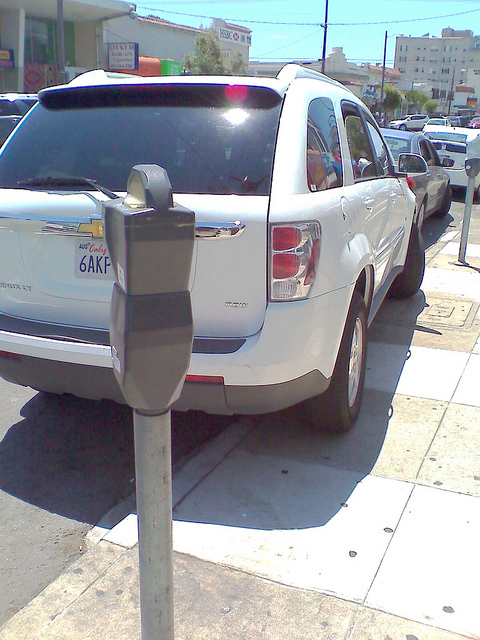Read and extract the text from this image. 6AKP 